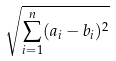Convert formula to latex. <formula><loc_0><loc_0><loc_500><loc_500>\sqrt { \sum _ { i = 1 } ^ { n } ( a _ { i } - b _ { i } ) ^ { 2 } }</formula> 